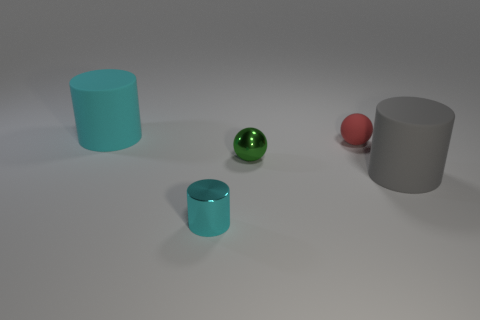Add 4 gray matte spheres. How many objects exist? 9 Subtract all spheres. How many objects are left? 3 Subtract all tiny red matte objects. Subtract all gray rubber objects. How many objects are left? 3 Add 5 big cyan matte objects. How many big cyan matte objects are left? 6 Add 2 big matte cylinders. How many big matte cylinders exist? 4 Subtract 0 blue spheres. How many objects are left? 5 